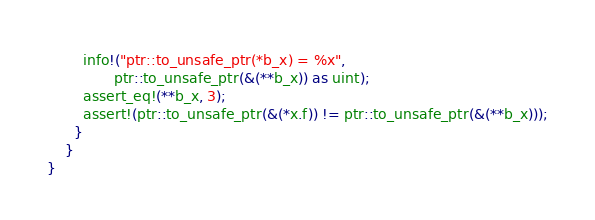Convert code to text. <code><loc_0><loc_0><loc_500><loc_500><_Rust_>        info!("ptr::to_unsafe_ptr(*b_x) = %x",
               ptr::to_unsafe_ptr(&(**b_x)) as uint);
        assert_eq!(**b_x, 3);
        assert!(ptr::to_unsafe_ptr(&(*x.f)) != ptr::to_unsafe_ptr(&(**b_x)));
      }
    }
}
</code> 